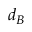Convert formula to latex. <formula><loc_0><loc_0><loc_500><loc_500>d _ { B }</formula> 